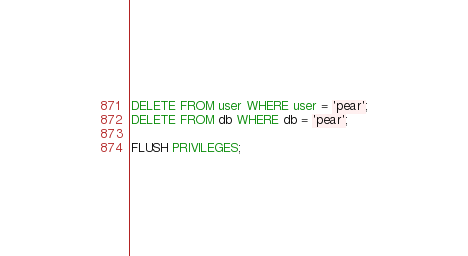Convert code to text. <code><loc_0><loc_0><loc_500><loc_500><_SQL_>
DELETE FROM user WHERE user = 'pear';
DELETE FROM db WHERE db = 'pear';

FLUSH PRIVILEGES;
</code> 